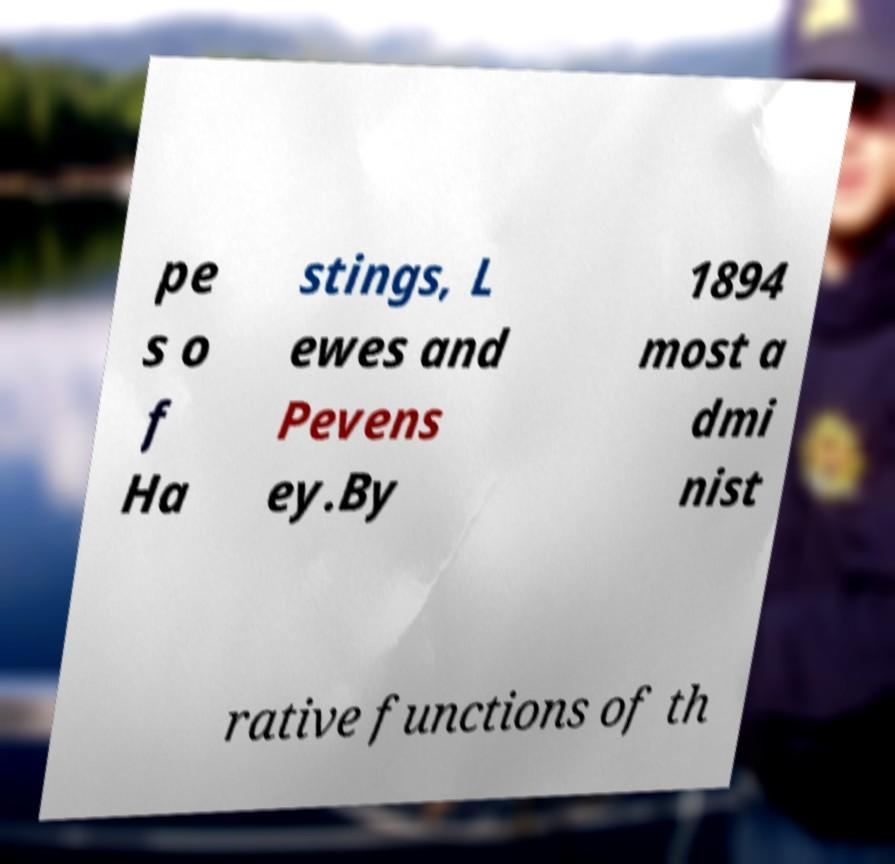I need the written content from this picture converted into text. Can you do that? pe s o f Ha stings, L ewes and Pevens ey.By 1894 most a dmi nist rative functions of th 